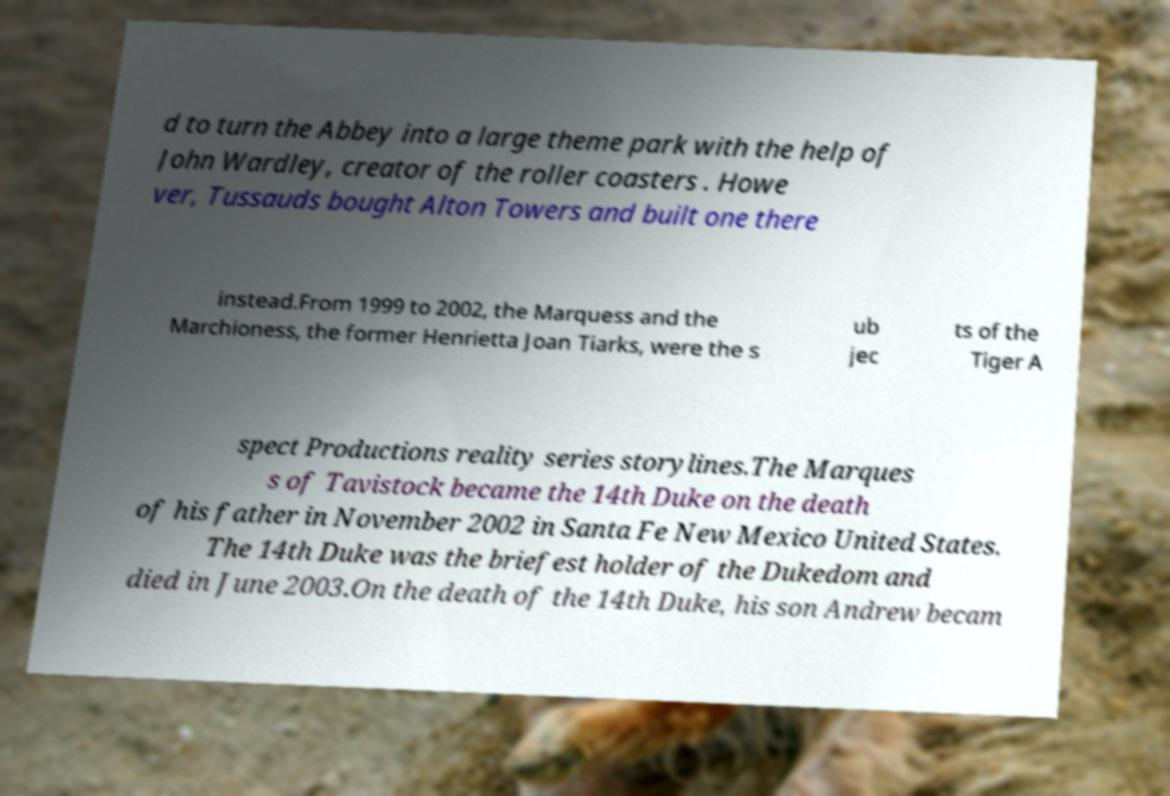What messages or text are displayed in this image? I need them in a readable, typed format. d to turn the Abbey into a large theme park with the help of John Wardley, creator of the roller coasters . Howe ver, Tussauds bought Alton Towers and built one there instead.From 1999 to 2002, the Marquess and the Marchioness, the former Henrietta Joan Tiarks, were the s ub jec ts of the Tiger A spect Productions reality series storylines.The Marques s of Tavistock became the 14th Duke on the death of his father in November 2002 in Santa Fe New Mexico United States. The 14th Duke was the briefest holder of the Dukedom and died in June 2003.On the death of the 14th Duke, his son Andrew becam 